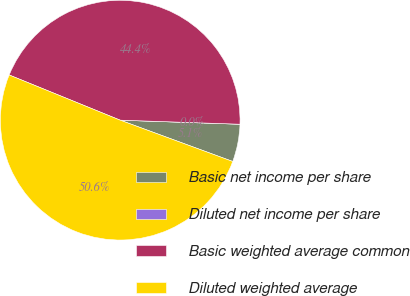Convert chart. <chart><loc_0><loc_0><loc_500><loc_500><pie_chart><fcel>Basic net income per share<fcel>Diluted net income per share<fcel>Basic weighted average common<fcel>Diluted weighted average<nl><fcel>5.06%<fcel>0.0%<fcel>44.39%<fcel>50.56%<nl></chart> 